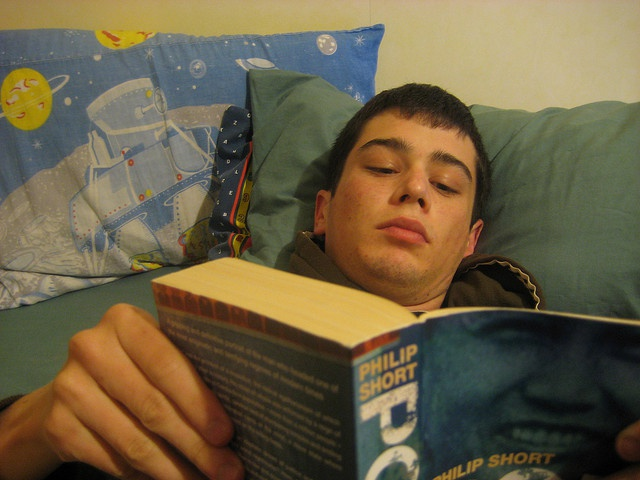Describe the objects in this image and their specific colors. I can see bed in olive, gray, darkgreen, and black tones, book in olive, black, tan, maroon, and purple tones, and people in olive, brown, black, and maroon tones in this image. 